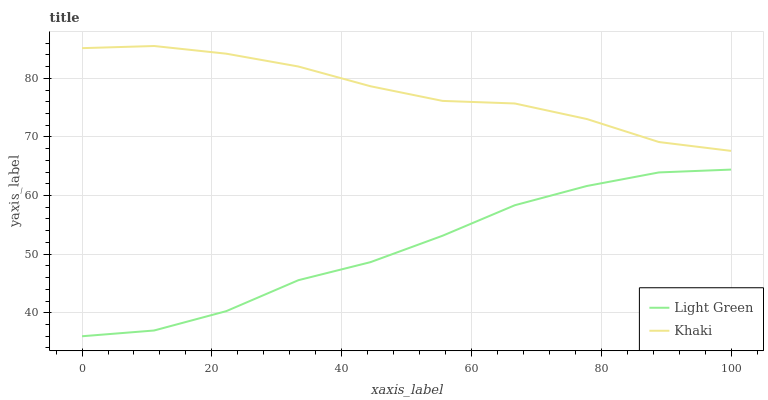Does Light Green have the minimum area under the curve?
Answer yes or no. Yes. Does Khaki have the maximum area under the curve?
Answer yes or no. Yes. Does Light Green have the maximum area under the curve?
Answer yes or no. No. Is Khaki the smoothest?
Answer yes or no. Yes. Is Light Green the roughest?
Answer yes or no. Yes. Is Light Green the smoothest?
Answer yes or no. No. Does Light Green have the lowest value?
Answer yes or no. Yes. Does Khaki have the highest value?
Answer yes or no. Yes. Does Light Green have the highest value?
Answer yes or no. No. Is Light Green less than Khaki?
Answer yes or no. Yes. Is Khaki greater than Light Green?
Answer yes or no. Yes. Does Light Green intersect Khaki?
Answer yes or no. No. 